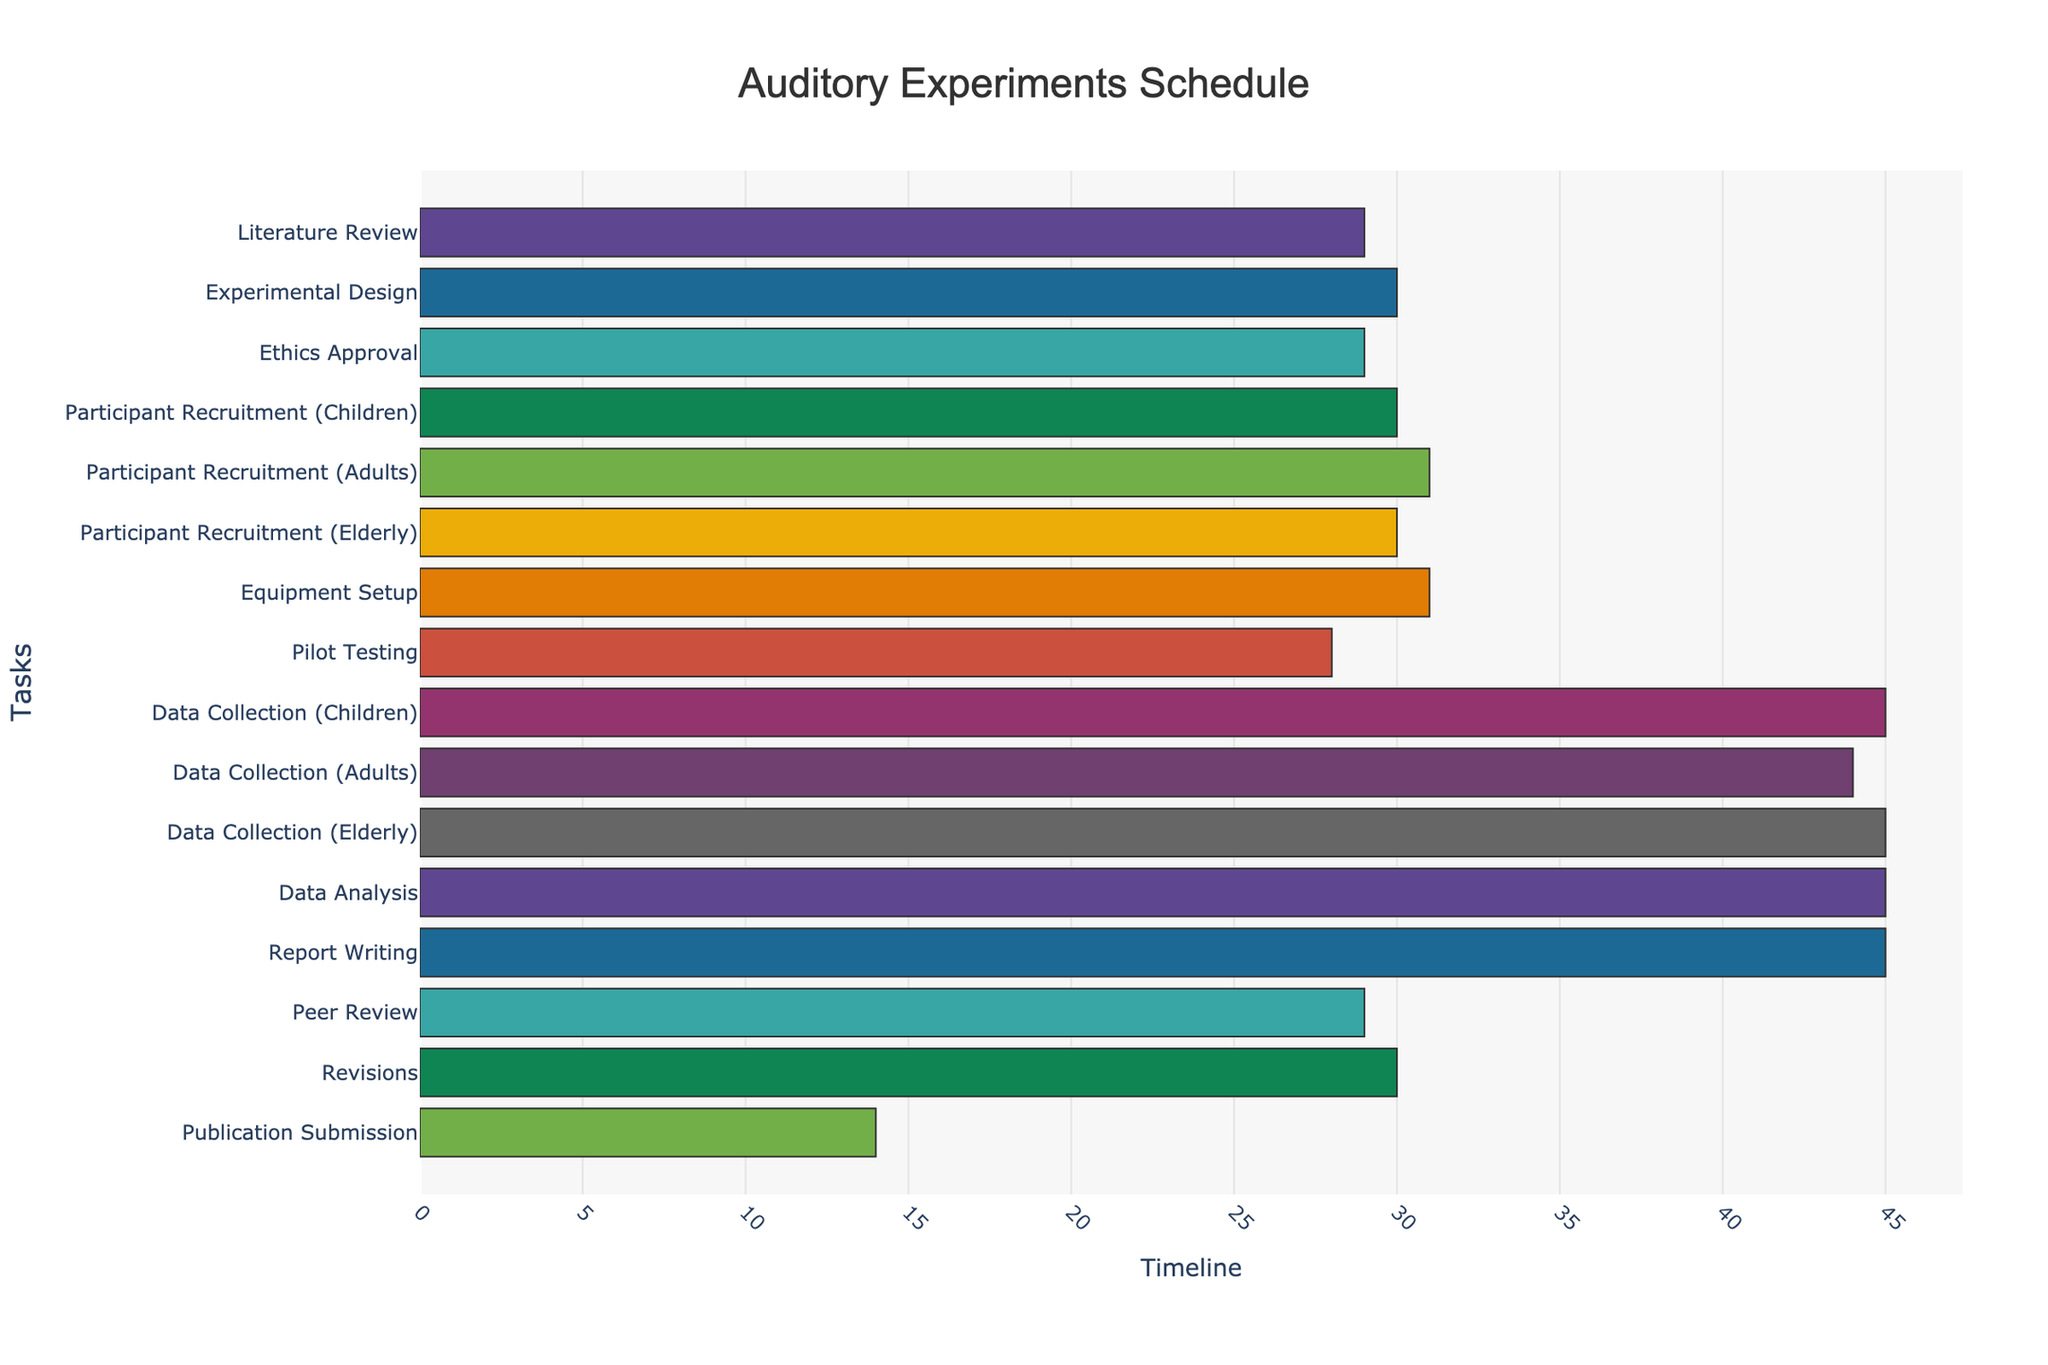What's the title of the Gantt Chart? The title is usually displayed at the top of the chart. In this chart, the title is 'Auditory Experiments Schedule'.
Answer: Auditory Experiments Schedule Which task starts the earliest and on what date? The task that starts earliest is the first task listed, which is 'Literature Review'. According to the chart, it begins on 2023-09-01.
Answer: Literature Review, 2023-09-01 How long does the 'Literature Review' task last? To determine the duration, calculate the difference between the start date and end date of the 'Literature Review' task. According to the Gantt chart, it starts on 2023-09-01 and ends on 2023-09-30, so the duration is 30 days.
Answer: 30 days What is the duration of 'Experimental Design' and how does it compare to 'Pilot Testing'? 'Experimental Design' lasts from 2023-10-01 to 2023-10-31, which is 31 days. 'Pilot Testing' is from 2024-02-16 to 2024-03-15, which is 29 days. Comparing the two, 'Experimental Design' is longer by 2 days.
Answer: 31 days, 2 days longer When does 'Data Collection (Adults)' start and end, and how long does it last? 'Data Collection (Adults)' starts on 2024-04-01 and ends on 2024-05-15. The duration is calculated by subtracting the start date from the end date. This results in a duration of 45 days.
Answer: 2024-04-01, 2024-05-15, 45 days What is the duration of 'Participant Recruitment (Children)' and how does it compare with 'Participant Recruitment (Adults)' and 'Participant Recruitment (Elderly)'? 'Participant Recruitment (Children)' lasts 31 days (2023-12-01 to 2023-12-31). 'Participant Recruitment (Adults)' lasts 32 days (2023-12-15 to 2024-01-15). 'Participant Recruitment (Elderly)' lasts 31 days (2024-01-01 to 2024-01-31). Comparing them, 'Participant Recruitment (Adults)' is 1 day longer than 'Participant Recruitment (Children)' and 'Participant Recruitment (Elderly)'.
Answer: 31 days, 1 day longer What tasks overlap with ' Equipment Setup'? 'Equipment Setup' spans from 2024-01-15 to 2024-02-15. According to the chart, this task overlaps with 'Participant Recruitment (Elderly)' (which ends on 2024-01-31) and 'Pilot Testing' (which starts on 2024-02-16).
Answer: Participant Recruitment (Elderly), Pilot Testing How many tasks are scheduled to occur simultaneously at the most, and during which period? To determine the maximum number of overlapping tasks, we observe each period where tasks coincide. The period with the most overlap is between 2024-01-15 and 2024-01-31, where 'Participant Recruitment (Adults)', 'Participant Recruitment (Elderly)', and 'Equipment Setup' are all active, making it three tasks.
Answer: 3 tasks, 2024-01-15 to 2024-01-31 What is the overall duration from the start of the 'Literature Review' to 'Publication Submission'? The overall duration is calculated from the start date of the 'Literature Review' (2023-09-01) to the end date of 'Publication Submission' (2024-11-30). This period spans 457 days.
Answer: 457 days 